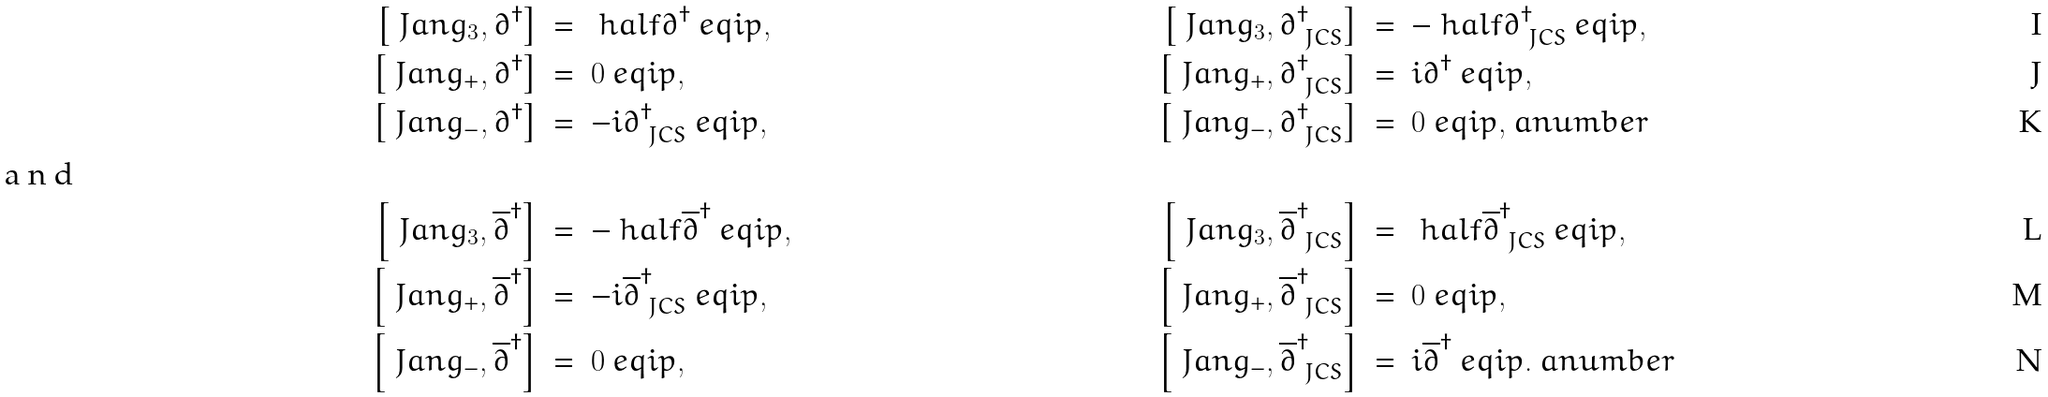Convert formula to latex. <formula><loc_0><loc_0><loc_500><loc_500>\left [ \ J a n g _ { 3 } , \partial ^ { \dag } \right ] & \ = \ \ h a l f \partial ^ { \dag } \ e q i p { , } & \left [ \ J a n g _ { 3 } , \partial _ { \ J C S } ^ { \dag } \right ] & \ = \ - \ h a l f \partial _ { \ J C S } ^ { \dag } \ e q i p { , } \\ \left [ \ J a n g _ { + } , \partial ^ { \dag } \right ] & \ = \ 0 \ e q i p { , } & \left [ \ J a n g _ { + } , \partial _ { \ J C S } ^ { \dag } \right ] & \ = \ i \partial ^ { \dag } \ e q i p { , } \\ \left [ \ J a n g _ { - } , \partial ^ { \dag } \right ] & \ = \ - i \partial _ { \ J C S } ^ { \dag } \ e q i p { , } & \left [ \ J a n g _ { - } , \partial _ { \ J C S } ^ { \dag } \right ] & \ = \ 0 \ e q i p { , } \ a n u m b e r \\ \intertext { a n d } \left [ \ J a n g _ { 3 } , \overline { \partial } ^ { \dag } \right ] & \ = \ - \ h a l f \overline { \partial } ^ { \dag } \ e q i p { , } & \left [ \ J a n g _ { 3 } , \overline { \partial } _ { \ J C S } ^ { \dag } \right ] & \ = \ \ h a l f \overline { \partial } _ { \ J C S } ^ { \dag } \ e q i p { , } \\ \left [ \ J a n g _ { + } , \overline { \partial } ^ { \dag } \right ] & \ = \ - i \overline { \partial } _ { \ J C S } ^ { \dag } \ e q i p { , } & \left [ \ J a n g _ { + } , \overline { \partial } _ { \ J C S } ^ { \dag } \right ] & \ = \ 0 \ e q i p { , } \\ \left [ \ J a n g _ { - } , \overline { \partial } ^ { \dag } \right ] & \ = \ 0 \ e q i p { , } & \left [ \ J a n g _ { - } , \overline { \partial } _ { \ J C S } ^ { \dag } \right ] & \ = \ i \overline { \partial } ^ { \dag } \ e q i p { . } \ a n u m b e r</formula> 